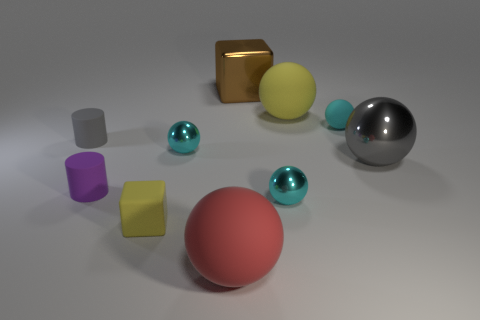What shape is the brown thing that is the same size as the yellow matte sphere?
Make the answer very short. Cube. What shape is the large metallic object in front of the big yellow thing?
Give a very brief answer. Sphere. Are there fewer rubber cubes in front of the yellow block than large rubber objects in front of the large metallic ball?
Your answer should be very brief. Yes. There is a purple matte object; is it the same size as the gray thing right of the big red rubber thing?
Your answer should be very brief. No. How many other objects are the same size as the brown metallic thing?
Provide a short and direct response. 3. There is a big object that is made of the same material as the big block; what color is it?
Make the answer very short. Gray. Is the number of small cylinders greater than the number of small yellow cubes?
Make the answer very short. Yes. Are the small gray object and the small purple object made of the same material?
Your answer should be very brief. Yes. There is a big gray thing that is made of the same material as the big brown object; what is its shape?
Keep it short and to the point. Sphere. Are there fewer big objects than small yellow matte things?
Provide a succinct answer. No. 